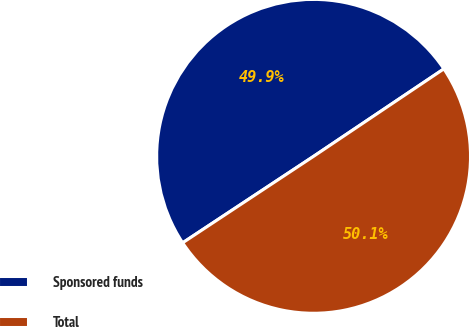<chart> <loc_0><loc_0><loc_500><loc_500><pie_chart><fcel>Sponsored funds<fcel>Total<nl><fcel>49.88%<fcel>50.12%<nl></chart> 